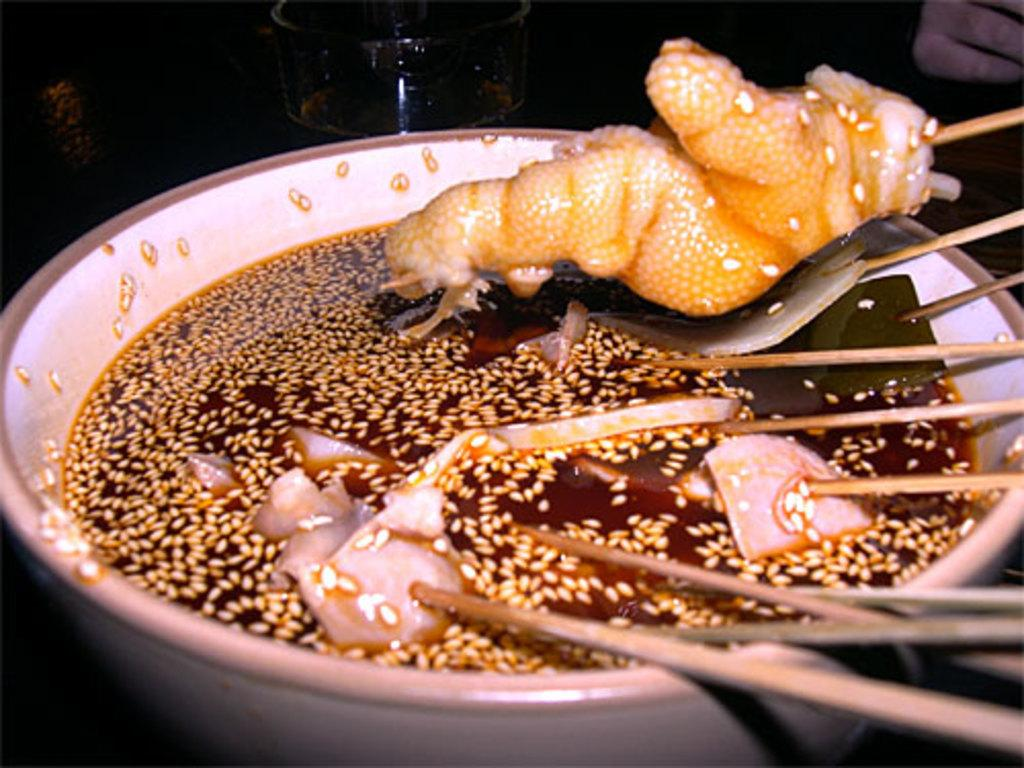What type of food can be seen in the image? There are food items in the image. What specific type of food is in the bowl? There are noodle sticks in a bowl. What else is present in the image besides the food? There is a glass with a drink in the image. Whose hand is visible in the image? A person's hand is visible in the image. What type of mountain can be seen in the background of the image? There is no mountain visible in the image. What is the view like from the low angle in the image? There is no indication of a low angle or a specific view in the image. 